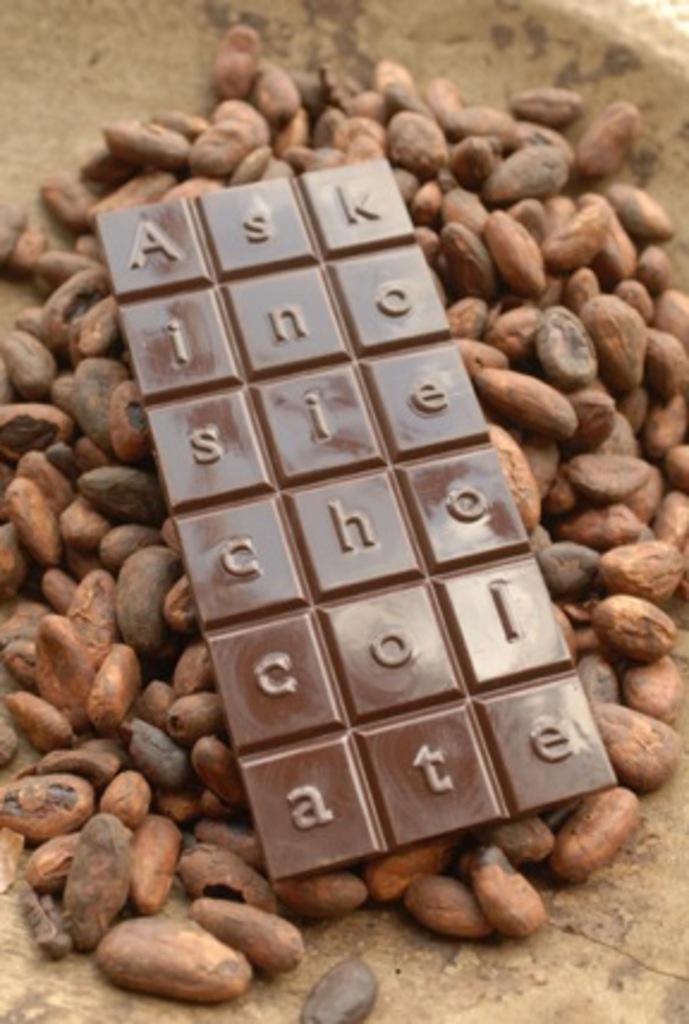Please provide a concise description of this image. In this image we can see a chocolate on the nuts. 